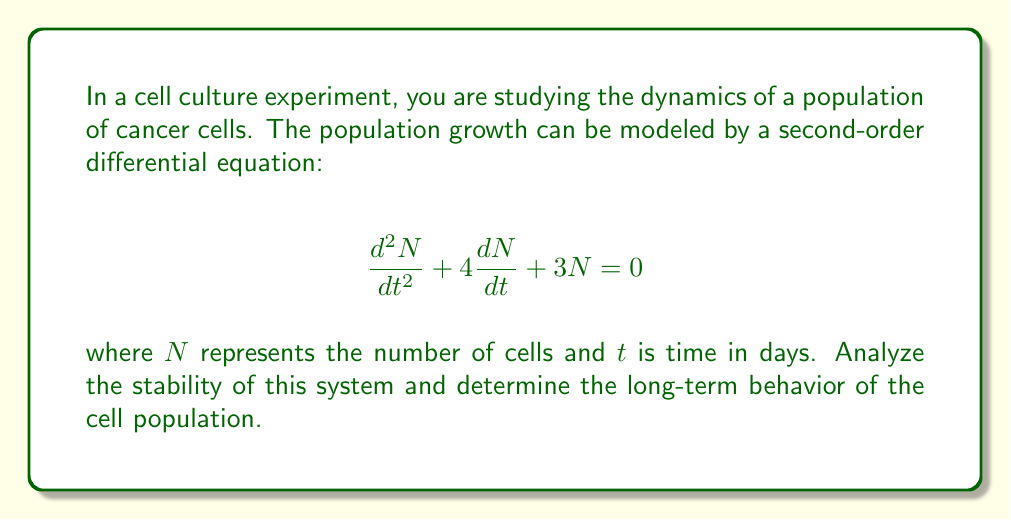Can you answer this question? To analyze the stability of this second-order system, we need to follow these steps:

1) First, we need to find the characteristic equation of the system. The characteristic equation is obtained by substituting $N = e^{rt}$ into the differential equation:

   $$r^2e^{rt} + 4re^{rt} + 3e^{rt} = 0$$

   Dividing by $e^{rt}$ (which is never zero), we get:

   $$r^2 + 4r + 3 = 0$$

2) This is our characteristic equation. We need to solve it to find the roots:

   $$r = \frac{-4 \pm \sqrt{4^2 - 4(1)(3)}}{2(1)} = \frac{-4 \pm \sqrt{16 - 12}}{2} = \frac{-4 \pm 2}{2}$$

   So, $r_1 = -1$ and $r_2 = -3$

3) The general solution to the differential equation is:

   $$N(t) = C_1e^{r_1t} + C_2e^{r_2t} = C_1e^{-t} + C_2e^{-3t}$$

   where $C_1$ and $C_2$ are constants determined by initial conditions.

4) To analyze stability, we look at the signs of the real parts of the roots:
   - Both roots are real and negative.
   - This means that both exponential terms in the solution will decay to zero as $t$ increases.

5) The long-term behavior of the system can be determined by looking at the limit as $t$ approaches infinity:

   $$\lim_{t \to \infty} N(t) = \lim_{t \to \infty} (C_1e^{-t} + C_2e^{-3t}) = 0$$

This indicates that the system is asymptotically stable, and the cell population will eventually die out regardless of the initial conditions.
Answer: The system is asymptotically stable. Both characteristic roots are real and negative ($r_1 = -1$ and $r_2 = -3$), indicating that the cell population will decay exponentially over time, approaching zero as $t \to \infty$, regardless of the initial conditions. 